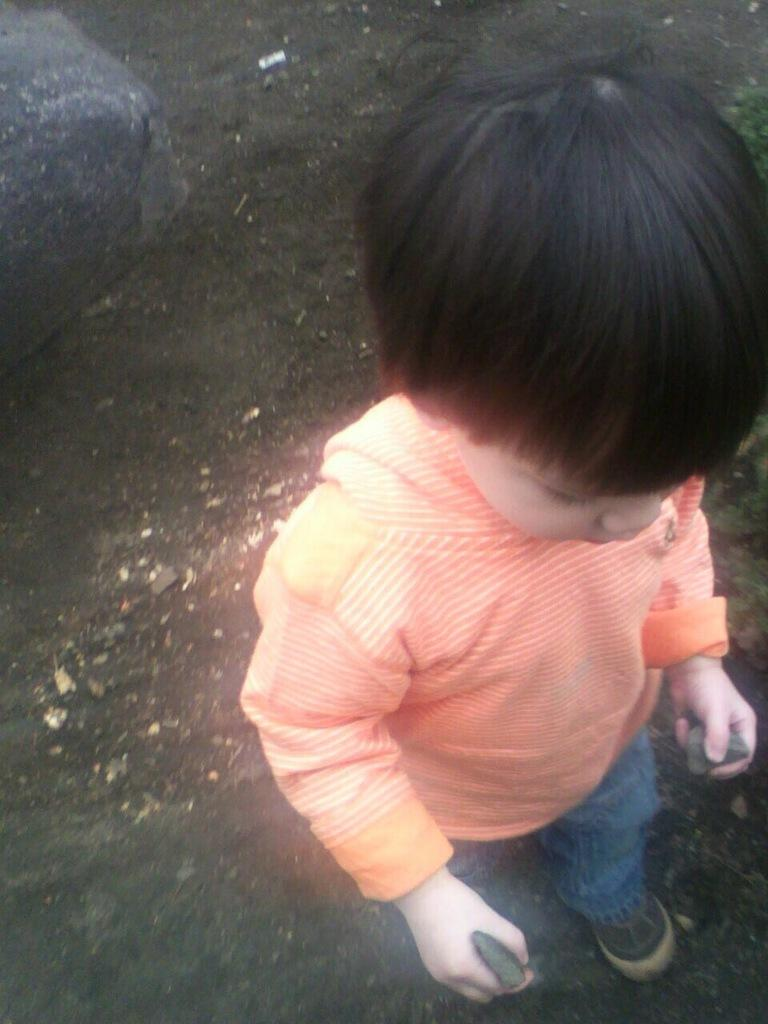Who is in the image? There is a boy in the image. What is the boy wearing? The boy is wearing blue jeans and shoes. What is the boy holding in the image? The boy is holding stones. Where is the boy standing? The boy is standing on land. Can you describe the background of the image? There is a stone visible in the background of the image. What type of impulse can be seen affecting the grass in the image? There is no grass present in the image, and therefore no impulse affecting it. How many oranges are visible in the image? There are no oranges present in the image. 